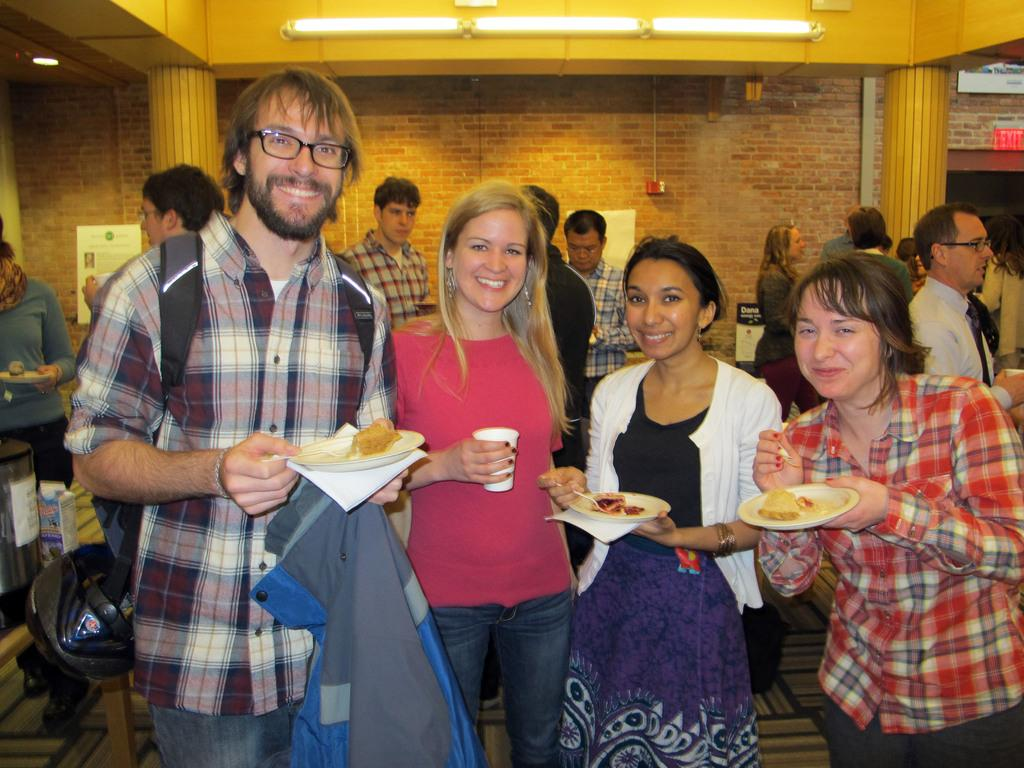What are the people in the image doing? The people in the image are standing and smiling. What are the people holding in their hands? The people are holding objects in their hands. What can be seen in the background of the image? There is a wall in the background of the image. How many cherries are on the slope in the image? There is no slope or cherries present in the image. What type of baseball equipment can be seen in the image? There is no baseball equipment present in the image. 